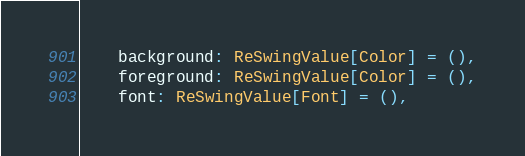<code> <loc_0><loc_0><loc_500><loc_500><_Scala_>    background: ReSwingValue[Color] = (),
    foreground: ReSwingValue[Color] = (),
    font: ReSwingValue[Font] = (),</code> 